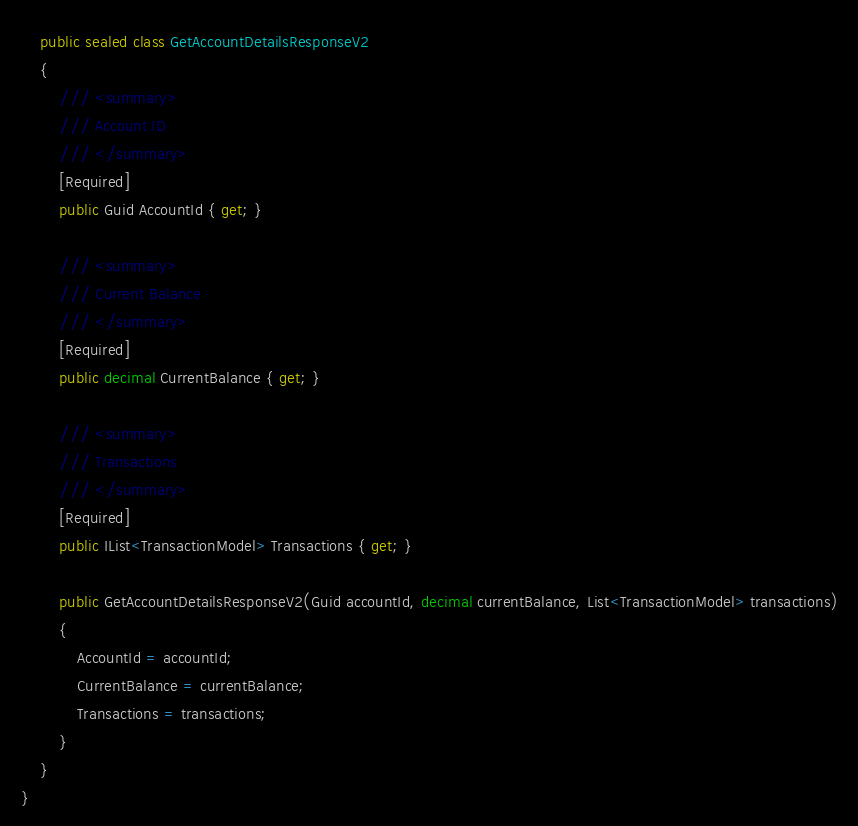<code> <loc_0><loc_0><loc_500><loc_500><_C#_>    public sealed class GetAccountDetailsResponseV2
    {
        /// <summary>
        /// Account ID
        /// </summary>
        [Required]
        public Guid AccountId { get; }

        /// <summary>
        /// Current Balance
        /// </summary>
        [Required]
        public decimal CurrentBalance { get; }

        /// <summary>
        /// Transactions
        /// </summary>
        [Required]
        public IList<TransactionModel> Transactions { get; }

        public GetAccountDetailsResponseV2(Guid accountId, decimal currentBalance, List<TransactionModel> transactions)
        {
            AccountId = accountId;
            CurrentBalance = currentBalance;
            Transactions = transactions;
        }
    }
}
</code> 